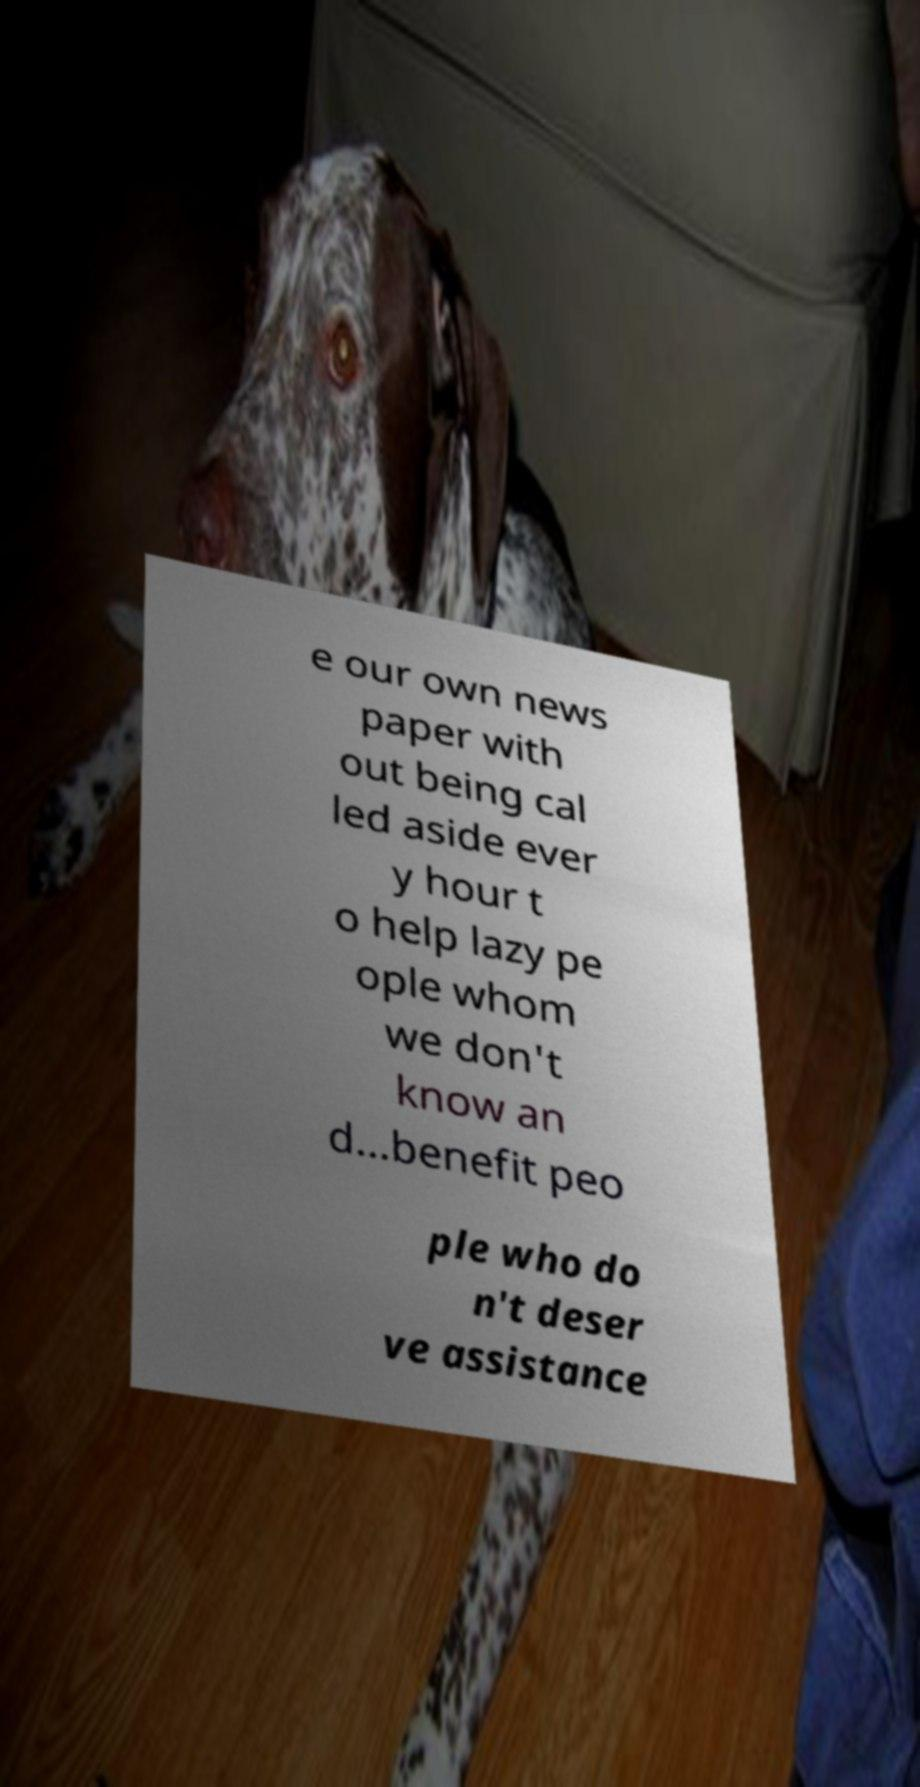Please identify and transcribe the text found in this image. e our own news paper with out being cal led aside ever y hour t o help lazy pe ople whom we don't know an d…benefit peo ple who do n't deser ve assistance 